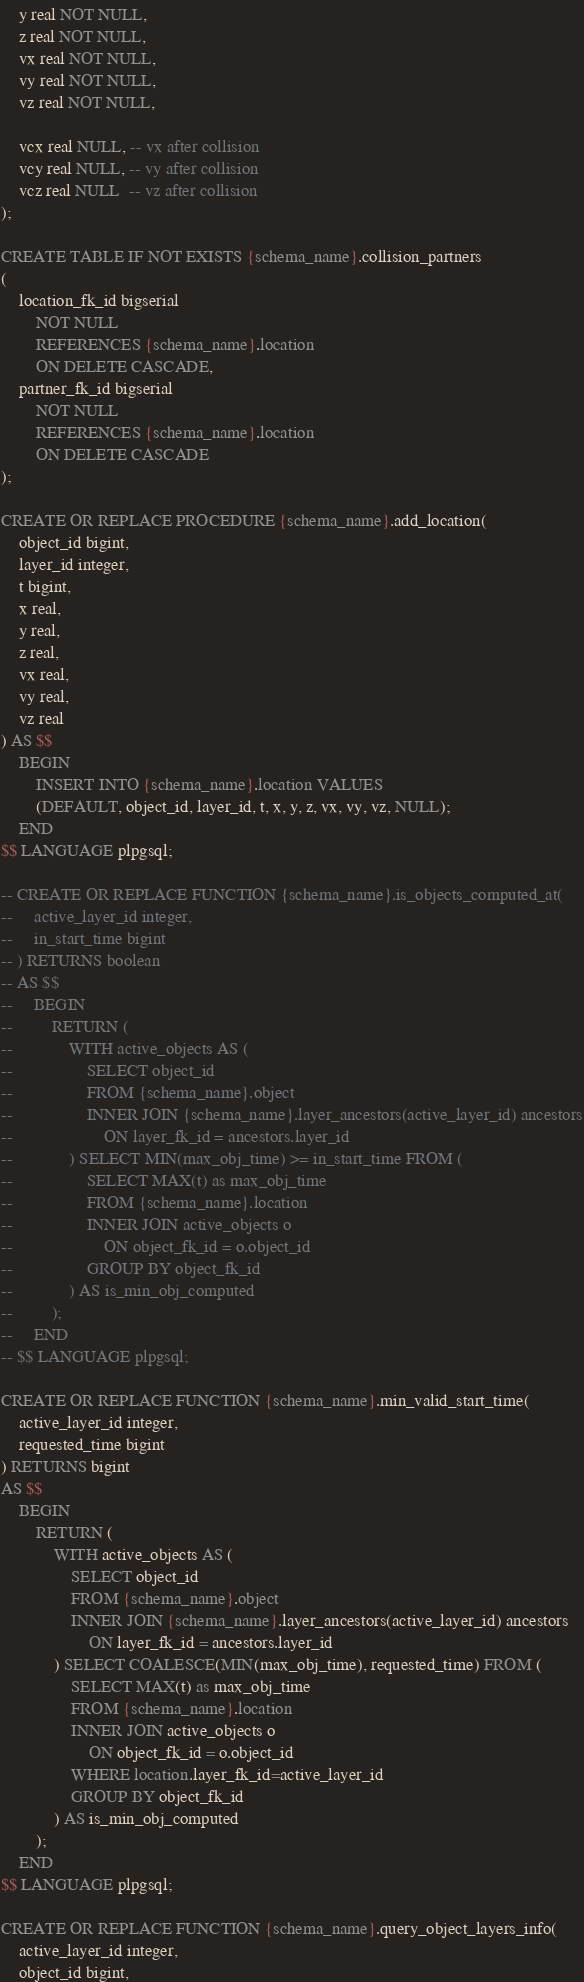Convert code to text. <code><loc_0><loc_0><loc_500><loc_500><_SQL_>    y real NOT NULL,
    z real NOT NULL,
    vx real NOT NULL,
    vy real NOT NULL,
    vz real NOT NULL,

    vcx real NULL, -- vx after collision
    vcy real NULL, -- vy after collision
    vcz real NULL  -- vz after collision
);

CREATE TABLE IF NOT EXISTS {schema_name}.collision_partners
(
    location_fk_id bigserial
        NOT NULL
        REFERENCES {schema_name}.location
        ON DELETE CASCADE,
    partner_fk_id bigserial
        NOT NULL
        REFERENCES {schema_name}.location
        ON DELETE CASCADE
);

CREATE OR REPLACE PROCEDURE {schema_name}.add_location(
    object_id bigint,
    layer_id integer,
    t bigint,
    x real,
    y real,
    z real,
    vx real,
    vy real,
    vz real
) AS $$
    BEGIN
        INSERT INTO {schema_name}.location VALUES
        (DEFAULT, object_id, layer_id, t, x, y, z, vx, vy, vz, NULL);
    END
$$ LANGUAGE plpgsql;

-- CREATE OR REPLACE FUNCTION {schema_name}.is_objects_computed_at(
--     active_layer_id integer,
--     in_start_time bigint
-- ) RETURNS boolean
-- AS $$
--     BEGIN
--         RETURN (
--             WITH active_objects AS (
--                 SELECT object_id
--                 FROM {schema_name}.object
--                 INNER JOIN {schema_name}.layer_ancestors(active_layer_id) ancestors
--                     ON layer_fk_id = ancestors.layer_id
--             ) SELECT MIN(max_obj_time) >= in_start_time FROM (
--                 SELECT MAX(t) as max_obj_time
--                 FROM {schema_name}.location
--                 INNER JOIN active_objects o
--                     ON object_fk_id = o.object_id
--                 GROUP BY object_fk_id
--             ) AS is_min_obj_computed
--         );
--     END
-- $$ LANGUAGE plpgsql;

CREATE OR REPLACE FUNCTION {schema_name}.min_valid_start_time(
    active_layer_id integer,
    requested_time bigint
) RETURNS bigint
AS $$
    BEGIN
        RETURN (
            WITH active_objects AS (
                SELECT object_id
                FROM {schema_name}.object
                INNER JOIN {schema_name}.layer_ancestors(active_layer_id) ancestors
                    ON layer_fk_id = ancestors.layer_id
            ) SELECT COALESCE(MIN(max_obj_time), requested_time) FROM (
                SELECT MAX(t) as max_obj_time
                FROM {schema_name}.location
                INNER JOIN active_objects o
                    ON object_fk_id = o.object_id
                WHERE location.layer_fk_id=active_layer_id
                GROUP BY object_fk_id
            ) AS is_min_obj_computed
        );
    END
$$ LANGUAGE plpgsql;

CREATE OR REPLACE FUNCTION {schema_name}.query_object_layers_info(
    active_layer_id integer,
    object_id bigint,</code> 